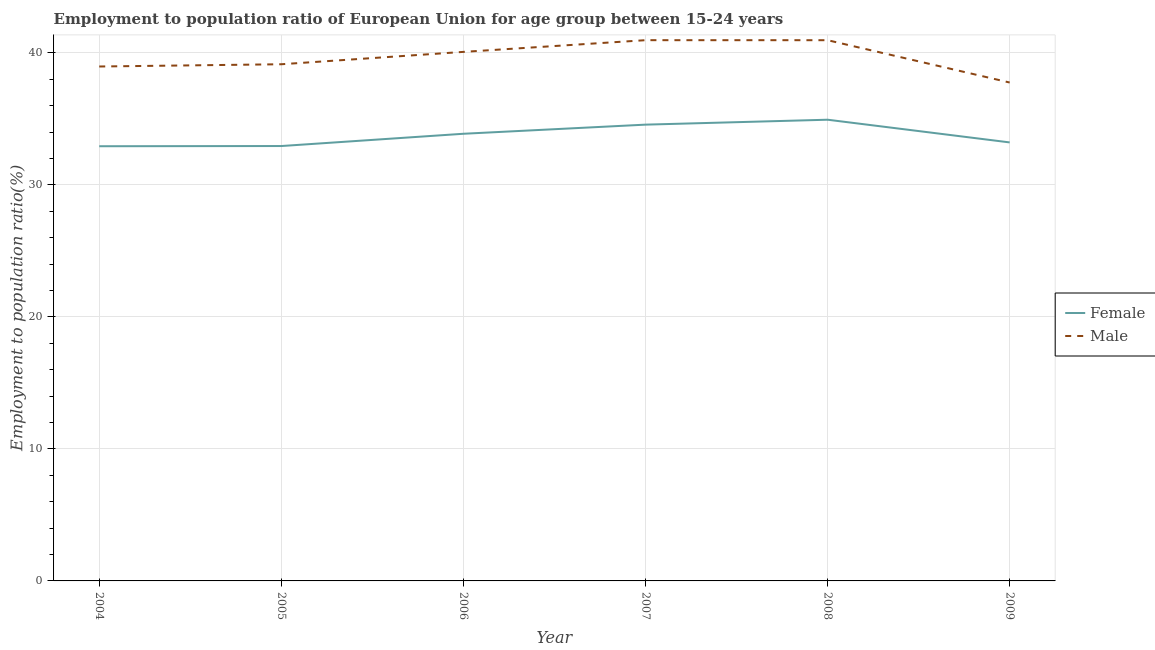How many different coloured lines are there?
Offer a terse response. 2. Does the line corresponding to employment to population ratio(male) intersect with the line corresponding to employment to population ratio(female)?
Offer a very short reply. No. What is the employment to population ratio(female) in 2006?
Keep it short and to the point. 33.87. Across all years, what is the maximum employment to population ratio(male)?
Provide a short and direct response. 40.96. Across all years, what is the minimum employment to population ratio(male)?
Ensure brevity in your answer.  37.75. In which year was the employment to population ratio(male) minimum?
Make the answer very short. 2009. What is the total employment to population ratio(male) in the graph?
Offer a very short reply. 237.84. What is the difference between the employment to population ratio(female) in 2004 and that in 2005?
Offer a terse response. -0.01. What is the difference between the employment to population ratio(female) in 2009 and the employment to population ratio(male) in 2004?
Give a very brief answer. -5.75. What is the average employment to population ratio(female) per year?
Your answer should be very brief. 33.74. In the year 2008, what is the difference between the employment to population ratio(female) and employment to population ratio(male)?
Your response must be concise. -6.02. In how many years, is the employment to population ratio(male) greater than 14 %?
Keep it short and to the point. 6. What is the ratio of the employment to population ratio(male) in 2006 to that in 2008?
Your response must be concise. 0.98. Is the difference between the employment to population ratio(female) in 2006 and 2008 greater than the difference between the employment to population ratio(male) in 2006 and 2008?
Give a very brief answer. No. What is the difference between the highest and the second highest employment to population ratio(female)?
Make the answer very short. 0.37. What is the difference between the highest and the lowest employment to population ratio(male)?
Offer a very short reply. 3.21. In how many years, is the employment to population ratio(female) greater than the average employment to population ratio(female) taken over all years?
Your answer should be compact. 3. Does the employment to population ratio(female) monotonically increase over the years?
Your answer should be compact. No. Is the employment to population ratio(female) strictly greater than the employment to population ratio(male) over the years?
Offer a terse response. No. How many lines are there?
Keep it short and to the point. 2. What is the difference between two consecutive major ticks on the Y-axis?
Keep it short and to the point. 10. Are the values on the major ticks of Y-axis written in scientific E-notation?
Offer a terse response. No. Does the graph contain grids?
Your answer should be compact. Yes. How many legend labels are there?
Make the answer very short. 2. How are the legend labels stacked?
Your answer should be very brief. Vertical. What is the title of the graph?
Keep it short and to the point. Employment to population ratio of European Union for age group between 15-24 years. Does "Not attending school" appear as one of the legend labels in the graph?
Your response must be concise. No. What is the label or title of the X-axis?
Keep it short and to the point. Year. What is the Employment to population ratio(%) of Female in 2004?
Your answer should be compact. 32.93. What is the Employment to population ratio(%) in Male in 2004?
Keep it short and to the point. 38.97. What is the Employment to population ratio(%) in Female in 2005?
Ensure brevity in your answer.  32.94. What is the Employment to population ratio(%) of Male in 2005?
Your response must be concise. 39.14. What is the Employment to population ratio(%) of Female in 2006?
Provide a short and direct response. 33.87. What is the Employment to population ratio(%) of Male in 2006?
Keep it short and to the point. 40.07. What is the Employment to population ratio(%) in Female in 2007?
Your response must be concise. 34.56. What is the Employment to population ratio(%) in Male in 2007?
Provide a succinct answer. 40.96. What is the Employment to population ratio(%) of Female in 2008?
Keep it short and to the point. 34.93. What is the Employment to population ratio(%) of Male in 2008?
Provide a succinct answer. 40.96. What is the Employment to population ratio(%) in Female in 2009?
Keep it short and to the point. 33.22. What is the Employment to population ratio(%) of Male in 2009?
Provide a succinct answer. 37.75. Across all years, what is the maximum Employment to population ratio(%) in Female?
Your response must be concise. 34.93. Across all years, what is the maximum Employment to population ratio(%) in Male?
Your response must be concise. 40.96. Across all years, what is the minimum Employment to population ratio(%) of Female?
Make the answer very short. 32.93. Across all years, what is the minimum Employment to population ratio(%) in Male?
Make the answer very short. 37.75. What is the total Employment to population ratio(%) in Female in the graph?
Keep it short and to the point. 202.45. What is the total Employment to population ratio(%) in Male in the graph?
Provide a short and direct response. 237.84. What is the difference between the Employment to population ratio(%) of Female in 2004 and that in 2005?
Your response must be concise. -0.01. What is the difference between the Employment to population ratio(%) of Male in 2004 and that in 2005?
Provide a succinct answer. -0.17. What is the difference between the Employment to population ratio(%) in Female in 2004 and that in 2006?
Provide a short and direct response. -0.94. What is the difference between the Employment to population ratio(%) of Male in 2004 and that in 2006?
Provide a succinct answer. -1.11. What is the difference between the Employment to population ratio(%) of Female in 2004 and that in 2007?
Ensure brevity in your answer.  -1.64. What is the difference between the Employment to population ratio(%) of Male in 2004 and that in 2007?
Ensure brevity in your answer.  -1.99. What is the difference between the Employment to population ratio(%) of Female in 2004 and that in 2008?
Ensure brevity in your answer.  -2.01. What is the difference between the Employment to population ratio(%) of Male in 2004 and that in 2008?
Offer a very short reply. -1.99. What is the difference between the Employment to population ratio(%) in Female in 2004 and that in 2009?
Provide a succinct answer. -0.29. What is the difference between the Employment to population ratio(%) of Male in 2004 and that in 2009?
Provide a short and direct response. 1.21. What is the difference between the Employment to population ratio(%) of Female in 2005 and that in 2006?
Offer a terse response. -0.93. What is the difference between the Employment to population ratio(%) of Male in 2005 and that in 2006?
Provide a short and direct response. -0.94. What is the difference between the Employment to population ratio(%) of Female in 2005 and that in 2007?
Ensure brevity in your answer.  -1.62. What is the difference between the Employment to population ratio(%) of Male in 2005 and that in 2007?
Provide a short and direct response. -1.82. What is the difference between the Employment to population ratio(%) in Female in 2005 and that in 2008?
Give a very brief answer. -1.99. What is the difference between the Employment to population ratio(%) of Male in 2005 and that in 2008?
Make the answer very short. -1.82. What is the difference between the Employment to population ratio(%) of Female in 2005 and that in 2009?
Provide a short and direct response. -0.27. What is the difference between the Employment to population ratio(%) in Male in 2005 and that in 2009?
Your response must be concise. 1.38. What is the difference between the Employment to population ratio(%) of Female in 2006 and that in 2007?
Your answer should be compact. -0.69. What is the difference between the Employment to population ratio(%) in Male in 2006 and that in 2007?
Your answer should be compact. -0.89. What is the difference between the Employment to population ratio(%) of Female in 2006 and that in 2008?
Offer a terse response. -1.06. What is the difference between the Employment to population ratio(%) in Male in 2006 and that in 2008?
Your response must be concise. -0.89. What is the difference between the Employment to population ratio(%) in Female in 2006 and that in 2009?
Give a very brief answer. 0.65. What is the difference between the Employment to population ratio(%) of Male in 2006 and that in 2009?
Offer a very short reply. 2.32. What is the difference between the Employment to population ratio(%) in Female in 2007 and that in 2008?
Keep it short and to the point. -0.37. What is the difference between the Employment to population ratio(%) in Male in 2007 and that in 2008?
Your answer should be compact. 0. What is the difference between the Employment to population ratio(%) in Female in 2007 and that in 2009?
Offer a terse response. 1.35. What is the difference between the Employment to population ratio(%) of Male in 2007 and that in 2009?
Ensure brevity in your answer.  3.21. What is the difference between the Employment to population ratio(%) in Female in 2008 and that in 2009?
Give a very brief answer. 1.72. What is the difference between the Employment to population ratio(%) of Male in 2008 and that in 2009?
Offer a very short reply. 3.21. What is the difference between the Employment to population ratio(%) in Female in 2004 and the Employment to population ratio(%) in Male in 2005?
Make the answer very short. -6.21. What is the difference between the Employment to population ratio(%) of Female in 2004 and the Employment to population ratio(%) of Male in 2006?
Ensure brevity in your answer.  -7.15. What is the difference between the Employment to population ratio(%) of Female in 2004 and the Employment to population ratio(%) of Male in 2007?
Offer a very short reply. -8.03. What is the difference between the Employment to population ratio(%) of Female in 2004 and the Employment to population ratio(%) of Male in 2008?
Keep it short and to the point. -8.03. What is the difference between the Employment to population ratio(%) in Female in 2004 and the Employment to population ratio(%) in Male in 2009?
Your answer should be very brief. -4.83. What is the difference between the Employment to population ratio(%) of Female in 2005 and the Employment to population ratio(%) of Male in 2006?
Keep it short and to the point. -7.13. What is the difference between the Employment to population ratio(%) of Female in 2005 and the Employment to population ratio(%) of Male in 2007?
Make the answer very short. -8.02. What is the difference between the Employment to population ratio(%) in Female in 2005 and the Employment to population ratio(%) in Male in 2008?
Offer a terse response. -8.02. What is the difference between the Employment to population ratio(%) in Female in 2005 and the Employment to population ratio(%) in Male in 2009?
Make the answer very short. -4.81. What is the difference between the Employment to population ratio(%) of Female in 2006 and the Employment to population ratio(%) of Male in 2007?
Make the answer very short. -7.09. What is the difference between the Employment to population ratio(%) of Female in 2006 and the Employment to population ratio(%) of Male in 2008?
Give a very brief answer. -7.09. What is the difference between the Employment to population ratio(%) of Female in 2006 and the Employment to population ratio(%) of Male in 2009?
Offer a very short reply. -3.88. What is the difference between the Employment to population ratio(%) of Female in 2007 and the Employment to population ratio(%) of Male in 2008?
Your answer should be compact. -6.4. What is the difference between the Employment to population ratio(%) of Female in 2007 and the Employment to population ratio(%) of Male in 2009?
Keep it short and to the point. -3.19. What is the difference between the Employment to population ratio(%) of Female in 2008 and the Employment to population ratio(%) of Male in 2009?
Ensure brevity in your answer.  -2.82. What is the average Employment to population ratio(%) of Female per year?
Offer a terse response. 33.74. What is the average Employment to population ratio(%) of Male per year?
Keep it short and to the point. 39.64. In the year 2004, what is the difference between the Employment to population ratio(%) of Female and Employment to population ratio(%) of Male?
Offer a terse response. -6.04. In the year 2005, what is the difference between the Employment to population ratio(%) of Female and Employment to population ratio(%) of Male?
Keep it short and to the point. -6.2. In the year 2006, what is the difference between the Employment to population ratio(%) in Female and Employment to population ratio(%) in Male?
Your answer should be very brief. -6.2. In the year 2007, what is the difference between the Employment to population ratio(%) of Female and Employment to population ratio(%) of Male?
Keep it short and to the point. -6.4. In the year 2008, what is the difference between the Employment to population ratio(%) in Female and Employment to population ratio(%) in Male?
Offer a terse response. -6.02. In the year 2009, what is the difference between the Employment to population ratio(%) of Female and Employment to population ratio(%) of Male?
Offer a very short reply. -4.54. What is the ratio of the Employment to population ratio(%) of Male in 2004 to that in 2005?
Ensure brevity in your answer.  1. What is the ratio of the Employment to population ratio(%) in Female in 2004 to that in 2006?
Offer a terse response. 0.97. What is the ratio of the Employment to population ratio(%) of Male in 2004 to that in 2006?
Provide a short and direct response. 0.97. What is the ratio of the Employment to population ratio(%) in Female in 2004 to that in 2007?
Your response must be concise. 0.95. What is the ratio of the Employment to population ratio(%) in Male in 2004 to that in 2007?
Offer a very short reply. 0.95. What is the ratio of the Employment to population ratio(%) of Female in 2004 to that in 2008?
Keep it short and to the point. 0.94. What is the ratio of the Employment to population ratio(%) of Male in 2004 to that in 2008?
Offer a very short reply. 0.95. What is the ratio of the Employment to population ratio(%) in Male in 2004 to that in 2009?
Make the answer very short. 1.03. What is the ratio of the Employment to population ratio(%) in Female in 2005 to that in 2006?
Your response must be concise. 0.97. What is the ratio of the Employment to population ratio(%) of Male in 2005 to that in 2006?
Provide a succinct answer. 0.98. What is the ratio of the Employment to population ratio(%) in Female in 2005 to that in 2007?
Give a very brief answer. 0.95. What is the ratio of the Employment to population ratio(%) of Male in 2005 to that in 2007?
Ensure brevity in your answer.  0.96. What is the ratio of the Employment to population ratio(%) in Female in 2005 to that in 2008?
Your response must be concise. 0.94. What is the ratio of the Employment to population ratio(%) of Male in 2005 to that in 2008?
Give a very brief answer. 0.96. What is the ratio of the Employment to population ratio(%) of Female in 2005 to that in 2009?
Make the answer very short. 0.99. What is the ratio of the Employment to population ratio(%) of Male in 2005 to that in 2009?
Ensure brevity in your answer.  1.04. What is the ratio of the Employment to population ratio(%) in Male in 2006 to that in 2007?
Your answer should be compact. 0.98. What is the ratio of the Employment to population ratio(%) in Female in 2006 to that in 2008?
Keep it short and to the point. 0.97. What is the ratio of the Employment to population ratio(%) in Male in 2006 to that in 2008?
Offer a terse response. 0.98. What is the ratio of the Employment to population ratio(%) in Female in 2006 to that in 2009?
Ensure brevity in your answer.  1.02. What is the ratio of the Employment to population ratio(%) in Male in 2006 to that in 2009?
Provide a succinct answer. 1.06. What is the ratio of the Employment to population ratio(%) of Female in 2007 to that in 2008?
Give a very brief answer. 0.99. What is the ratio of the Employment to population ratio(%) in Male in 2007 to that in 2008?
Offer a very short reply. 1. What is the ratio of the Employment to population ratio(%) of Female in 2007 to that in 2009?
Ensure brevity in your answer.  1.04. What is the ratio of the Employment to population ratio(%) in Male in 2007 to that in 2009?
Provide a succinct answer. 1.08. What is the ratio of the Employment to population ratio(%) in Female in 2008 to that in 2009?
Make the answer very short. 1.05. What is the ratio of the Employment to population ratio(%) of Male in 2008 to that in 2009?
Provide a short and direct response. 1.08. What is the difference between the highest and the second highest Employment to population ratio(%) of Female?
Give a very brief answer. 0.37. What is the difference between the highest and the second highest Employment to population ratio(%) in Male?
Offer a very short reply. 0. What is the difference between the highest and the lowest Employment to population ratio(%) of Female?
Offer a very short reply. 2.01. What is the difference between the highest and the lowest Employment to population ratio(%) of Male?
Provide a short and direct response. 3.21. 